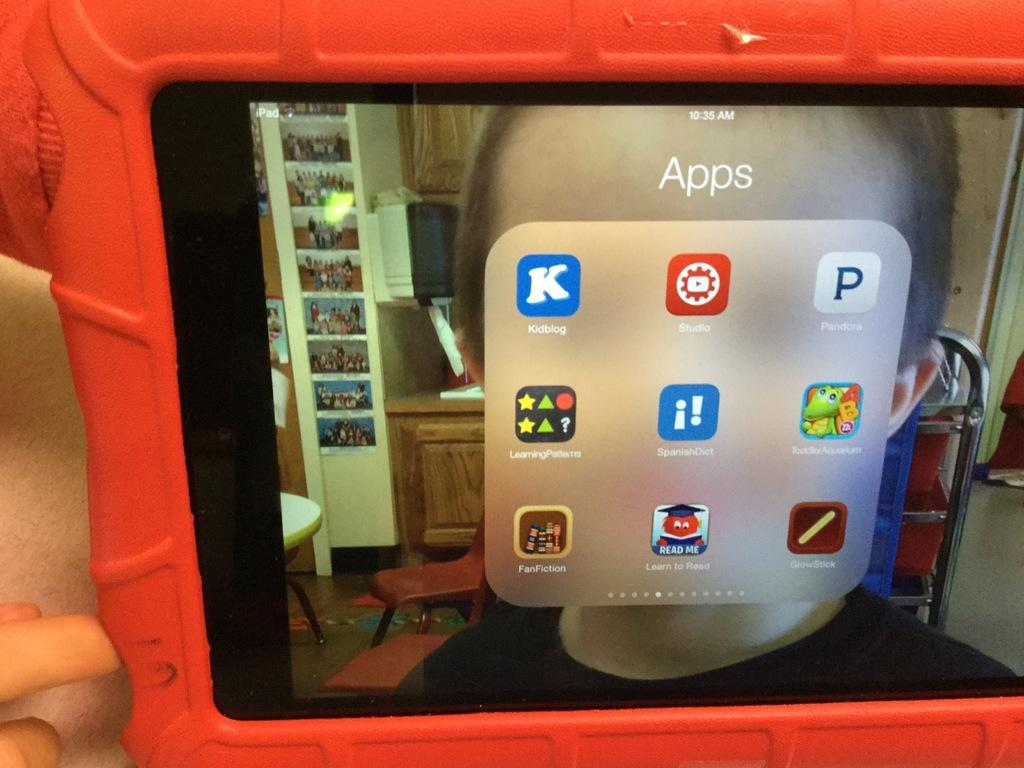<image>
Provide a brief description of the given image. The word Apps is on a screen with a red border. 